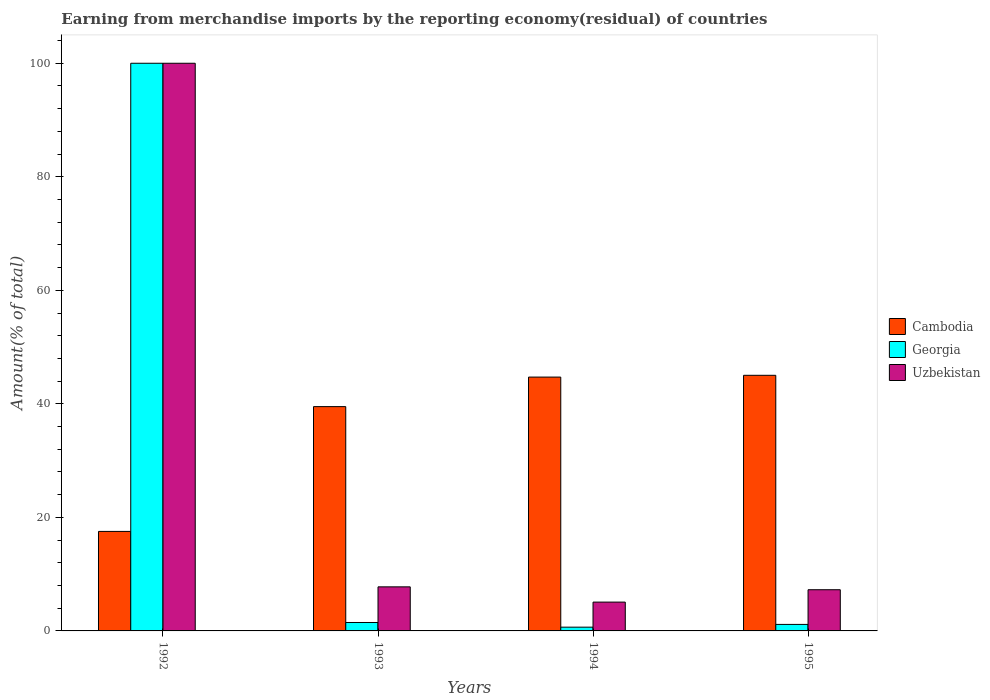How many different coloured bars are there?
Ensure brevity in your answer.  3. Are the number of bars per tick equal to the number of legend labels?
Keep it short and to the point. Yes. Are the number of bars on each tick of the X-axis equal?
Provide a succinct answer. Yes. How many bars are there on the 4th tick from the right?
Give a very brief answer. 3. What is the label of the 2nd group of bars from the left?
Give a very brief answer. 1993. In how many cases, is the number of bars for a given year not equal to the number of legend labels?
Give a very brief answer. 0. What is the percentage of amount earned from merchandise imports in Georgia in 1995?
Ensure brevity in your answer.  1.15. Across all years, what is the minimum percentage of amount earned from merchandise imports in Uzbekistan?
Keep it short and to the point. 5.08. In which year was the percentage of amount earned from merchandise imports in Cambodia maximum?
Offer a very short reply. 1995. In which year was the percentage of amount earned from merchandise imports in Uzbekistan minimum?
Keep it short and to the point. 1994. What is the total percentage of amount earned from merchandise imports in Georgia in the graph?
Your answer should be compact. 103.29. What is the difference between the percentage of amount earned from merchandise imports in Uzbekistan in 1993 and that in 1994?
Make the answer very short. 2.69. What is the difference between the percentage of amount earned from merchandise imports in Uzbekistan in 1992 and the percentage of amount earned from merchandise imports in Cambodia in 1995?
Provide a succinct answer. 54.97. What is the average percentage of amount earned from merchandise imports in Uzbekistan per year?
Your answer should be compact. 30.02. In the year 1992, what is the difference between the percentage of amount earned from merchandise imports in Cambodia and percentage of amount earned from merchandise imports in Uzbekistan?
Your answer should be very brief. -82.47. What is the ratio of the percentage of amount earned from merchandise imports in Uzbekistan in 1993 to that in 1995?
Give a very brief answer. 1.07. Is the difference between the percentage of amount earned from merchandise imports in Cambodia in 1992 and 1995 greater than the difference between the percentage of amount earned from merchandise imports in Uzbekistan in 1992 and 1995?
Ensure brevity in your answer.  No. What is the difference between the highest and the second highest percentage of amount earned from merchandise imports in Georgia?
Your answer should be very brief. 98.51. What is the difference between the highest and the lowest percentage of amount earned from merchandise imports in Georgia?
Your response must be concise. 99.34. Is the sum of the percentage of amount earned from merchandise imports in Cambodia in 1993 and 1995 greater than the maximum percentage of amount earned from merchandise imports in Uzbekistan across all years?
Keep it short and to the point. No. What does the 1st bar from the left in 1993 represents?
Keep it short and to the point. Cambodia. What does the 1st bar from the right in 1993 represents?
Make the answer very short. Uzbekistan. Is it the case that in every year, the sum of the percentage of amount earned from merchandise imports in Cambodia and percentage of amount earned from merchandise imports in Georgia is greater than the percentage of amount earned from merchandise imports in Uzbekistan?
Offer a very short reply. Yes. Are all the bars in the graph horizontal?
Give a very brief answer. No. How many years are there in the graph?
Make the answer very short. 4. What is the difference between two consecutive major ticks on the Y-axis?
Your answer should be compact. 20. Does the graph contain any zero values?
Offer a terse response. No. How many legend labels are there?
Ensure brevity in your answer.  3. How are the legend labels stacked?
Your response must be concise. Vertical. What is the title of the graph?
Keep it short and to the point. Earning from merchandise imports by the reporting economy(residual) of countries. Does "Philippines" appear as one of the legend labels in the graph?
Your response must be concise. No. What is the label or title of the X-axis?
Offer a terse response. Years. What is the label or title of the Y-axis?
Keep it short and to the point. Amount(% of total). What is the Amount(% of total) in Cambodia in 1992?
Provide a short and direct response. 17.53. What is the Amount(% of total) in Georgia in 1992?
Provide a succinct answer. 100. What is the Amount(% of total) of Uzbekistan in 1992?
Keep it short and to the point. 100. What is the Amount(% of total) in Cambodia in 1993?
Your answer should be very brief. 39.51. What is the Amount(% of total) in Georgia in 1993?
Provide a succinct answer. 1.49. What is the Amount(% of total) in Uzbekistan in 1993?
Your response must be concise. 7.76. What is the Amount(% of total) in Cambodia in 1994?
Your answer should be very brief. 44.72. What is the Amount(% of total) in Georgia in 1994?
Offer a very short reply. 0.66. What is the Amount(% of total) of Uzbekistan in 1994?
Provide a short and direct response. 5.08. What is the Amount(% of total) of Cambodia in 1995?
Your response must be concise. 45.03. What is the Amount(% of total) in Georgia in 1995?
Make the answer very short. 1.15. What is the Amount(% of total) in Uzbekistan in 1995?
Give a very brief answer. 7.26. Across all years, what is the maximum Amount(% of total) of Cambodia?
Your response must be concise. 45.03. Across all years, what is the maximum Amount(% of total) in Uzbekistan?
Make the answer very short. 100. Across all years, what is the minimum Amount(% of total) of Cambodia?
Your response must be concise. 17.53. Across all years, what is the minimum Amount(% of total) in Georgia?
Provide a short and direct response. 0.66. Across all years, what is the minimum Amount(% of total) in Uzbekistan?
Give a very brief answer. 5.08. What is the total Amount(% of total) of Cambodia in the graph?
Provide a short and direct response. 146.79. What is the total Amount(% of total) in Georgia in the graph?
Make the answer very short. 103.29. What is the total Amount(% of total) in Uzbekistan in the graph?
Offer a very short reply. 120.1. What is the difference between the Amount(% of total) in Cambodia in 1992 and that in 1993?
Provide a short and direct response. -21.98. What is the difference between the Amount(% of total) of Georgia in 1992 and that in 1993?
Your answer should be very brief. 98.51. What is the difference between the Amount(% of total) of Uzbekistan in 1992 and that in 1993?
Offer a terse response. 92.24. What is the difference between the Amount(% of total) in Cambodia in 1992 and that in 1994?
Offer a terse response. -27.19. What is the difference between the Amount(% of total) in Georgia in 1992 and that in 1994?
Keep it short and to the point. 99.34. What is the difference between the Amount(% of total) in Uzbekistan in 1992 and that in 1994?
Ensure brevity in your answer.  94.92. What is the difference between the Amount(% of total) in Cambodia in 1992 and that in 1995?
Your answer should be very brief. -27.5. What is the difference between the Amount(% of total) in Georgia in 1992 and that in 1995?
Offer a very short reply. 98.85. What is the difference between the Amount(% of total) of Uzbekistan in 1992 and that in 1995?
Your answer should be very brief. 92.74. What is the difference between the Amount(% of total) in Cambodia in 1993 and that in 1994?
Make the answer very short. -5.2. What is the difference between the Amount(% of total) of Georgia in 1993 and that in 1994?
Give a very brief answer. 0.83. What is the difference between the Amount(% of total) in Uzbekistan in 1993 and that in 1994?
Give a very brief answer. 2.69. What is the difference between the Amount(% of total) of Cambodia in 1993 and that in 1995?
Offer a very short reply. -5.52. What is the difference between the Amount(% of total) in Georgia in 1993 and that in 1995?
Give a very brief answer. 0.34. What is the difference between the Amount(% of total) of Uzbekistan in 1993 and that in 1995?
Make the answer very short. 0.51. What is the difference between the Amount(% of total) in Cambodia in 1994 and that in 1995?
Give a very brief answer. -0.31. What is the difference between the Amount(% of total) in Georgia in 1994 and that in 1995?
Offer a terse response. -0.49. What is the difference between the Amount(% of total) of Uzbekistan in 1994 and that in 1995?
Offer a very short reply. -2.18. What is the difference between the Amount(% of total) of Cambodia in 1992 and the Amount(% of total) of Georgia in 1993?
Make the answer very short. 16.04. What is the difference between the Amount(% of total) of Cambodia in 1992 and the Amount(% of total) of Uzbekistan in 1993?
Your response must be concise. 9.77. What is the difference between the Amount(% of total) of Georgia in 1992 and the Amount(% of total) of Uzbekistan in 1993?
Your answer should be very brief. 92.24. What is the difference between the Amount(% of total) of Cambodia in 1992 and the Amount(% of total) of Georgia in 1994?
Your answer should be very brief. 16.87. What is the difference between the Amount(% of total) in Cambodia in 1992 and the Amount(% of total) in Uzbekistan in 1994?
Give a very brief answer. 12.45. What is the difference between the Amount(% of total) in Georgia in 1992 and the Amount(% of total) in Uzbekistan in 1994?
Offer a very short reply. 94.92. What is the difference between the Amount(% of total) in Cambodia in 1992 and the Amount(% of total) in Georgia in 1995?
Provide a short and direct response. 16.38. What is the difference between the Amount(% of total) in Cambodia in 1992 and the Amount(% of total) in Uzbekistan in 1995?
Provide a short and direct response. 10.27. What is the difference between the Amount(% of total) of Georgia in 1992 and the Amount(% of total) of Uzbekistan in 1995?
Offer a very short reply. 92.74. What is the difference between the Amount(% of total) of Cambodia in 1993 and the Amount(% of total) of Georgia in 1994?
Offer a terse response. 38.85. What is the difference between the Amount(% of total) of Cambodia in 1993 and the Amount(% of total) of Uzbekistan in 1994?
Your answer should be very brief. 34.44. What is the difference between the Amount(% of total) of Georgia in 1993 and the Amount(% of total) of Uzbekistan in 1994?
Your response must be concise. -3.59. What is the difference between the Amount(% of total) of Cambodia in 1993 and the Amount(% of total) of Georgia in 1995?
Offer a very short reply. 38.37. What is the difference between the Amount(% of total) in Cambodia in 1993 and the Amount(% of total) in Uzbekistan in 1995?
Your response must be concise. 32.26. What is the difference between the Amount(% of total) in Georgia in 1993 and the Amount(% of total) in Uzbekistan in 1995?
Ensure brevity in your answer.  -5.77. What is the difference between the Amount(% of total) in Cambodia in 1994 and the Amount(% of total) in Georgia in 1995?
Offer a terse response. 43.57. What is the difference between the Amount(% of total) in Cambodia in 1994 and the Amount(% of total) in Uzbekistan in 1995?
Your response must be concise. 37.46. What is the difference between the Amount(% of total) of Georgia in 1994 and the Amount(% of total) of Uzbekistan in 1995?
Provide a succinct answer. -6.6. What is the average Amount(% of total) of Cambodia per year?
Offer a terse response. 36.7. What is the average Amount(% of total) in Georgia per year?
Ensure brevity in your answer.  25.82. What is the average Amount(% of total) in Uzbekistan per year?
Ensure brevity in your answer.  30.02. In the year 1992, what is the difference between the Amount(% of total) of Cambodia and Amount(% of total) of Georgia?
Provide a succinct answer. -82.47. In the year 1992, what is the difference between the Amount(% of total) in Cambodia and Amount(% of total) in Uzbekistan?
Provide a short and direct response. -82.47. In the year 1992, what is the difference between the Amount(% of total) in Georgia and Amount(% of total) in Uzbekistan?
Offer a very short reply. 0. In the year 1993, what is the difference between the Amount(% of total) of Cambodia and Amount(% of total) of Georgia?
Offer a terse response. 38.03. In the year 1993, what is the difference between the Amount(% of total) in Cambodia and Amount(% of total) in Uzbekistan?
Your answer should be very brief. 31.75. In the year 1993, what is the difference between the Amount(% of total) in Georgia and Amount(% of total) in Uzbekistan?
Your answer should be compact. -6.28. In the year 1994, what is the difference between the Amount(% of total) of Cambodia and Amount(% of total) of Georgia?
Your answer should be very brief. 44.06. In the year 1994, what is the difference between the Amount(% of total) in Cambodia and Amount(% of total) in Uzbekistan?
Provide a succinct answer. 39.64. In the year 1994, what is the difference between the Amount(% of total) of Georgia and Amount(% of total) of Uzbekistan?
Your response must be concise. -4.42. In the year 1995, what is the difference between the Amount(% of total) of Cambodia and Amount(% of total) of Georgia?
Provide a succinct answer. 43.88. In the year 1995, what is the difference between the Amount(% of total) in Cambodia and Amount(% of total) in Uzbekistan?
Offer a very short reply. 37.77. In the year 1995, what is the difference between the Amount(% of total) in Georgia and Amount(% of total) in Uzbekistan?
Provide a short and direct response. -6.11. What is the ratio of the Amount(% of total) in Cambodia in 1992 to that in 1993?
Keep it short and to the point. 0.44. What is the ratio of the Amount(% of total) in Georgia in 1992 to that in 1993?
Give a very brief answer. 67.3. What is the ratio of the Amount(% of total) of Uzbekistan in 1992 to that in 1993?
Offer a very short reply. 12.88. What is the ratio of the Amount(% of total) of Cambodia in 1992 to that in 1994?
Your answer should be very brief. 0.39. What is the ratio of the Amount(% of total) in Georgia in 1992 to that in 1994?
Provide a succinct answer. 151.35. What is the ratio of the Amount(% of total) in Uzbekistan in 1992 to that in 1994?
Your answer should be compact. 19.7. What is the ratio of the Amount(% of total) of Cambodia in 1992 to that in 1995?
Keep it short and to the point. 0.39. What is the ratio of the Amount(% of total) of Georgia in 1992 to that in 1995?
Provide a short and direct response. 87.16. What is the ratio of the Amount(% of total) in Uzbekistan in 1992 to that in 1995?
Provide a short and direct response. 13.78. What is the ratio of the Amount(% of total) in Cambodia in 1993 to that in 1994?
Make the answer very short. 0.88. What is the ratio of the Amount(% of total) in Georgia in 1993 to that in 1994?
Provide a succinct answer. 2.25. What is the ratio of the Amount(% of total) of Uzbekistan in 1993 to that in 1994?
Offer a very short reply. 1.53. What is the ratio of the Amount(% of total) of Cambodia in 1993 to that in 1995?
Your response must be concise. 0.88. What is the ratio of the Amount(% of total) in Georgia in 1993 to that in 1995?
Your answer should be compact. 1.29. What is the ratio of the Amount(% of total) of Uzbekistan in 1993 to that in 1995?
Offer a very short reply. 1.07. What is the ratio of the Amount(% of total) in Georgia in 1994 to that in 1995?
Keep it short and to the point. 0.58. What is the ratio of the Amount(% of total) in Uzbekistan in 1994 to that in 1995?
Your response must be concise. 0.7. What is the difference between the highest and the second highest Amount(% of total) in Cambodia?
Make the answer very short. 0.31. What is the difference between the highest and the second highest Amount(% of total) of Georgia?
Offer a terse response. 98.51. What is the difference between the highest and the second highest Amount(% of total) in Uzbekistan?
Offer a terse response. 92.24. What is the difference between the highest and the lowest Amount(% of total) of Cambodia?
Make the answer very short. 27.5. What is the difference between the highest and the lowest Amount(% of total) in Georgia?
Keep it short and to the point. 99.34. What is the difference between the highest and the lowest Amount(% of total) of Uzbekistan?
Offer a terse response. 94.92. 